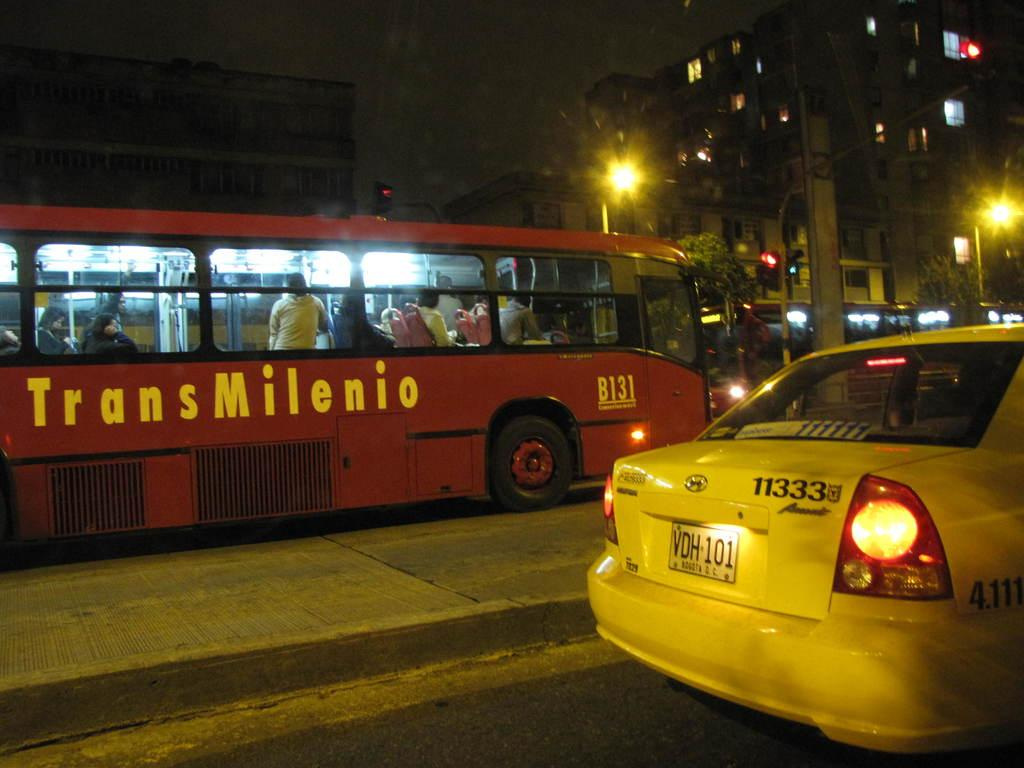<image>
Offer a succinct explanation of the picture presented. A red bus from the Trans Milenio line. 